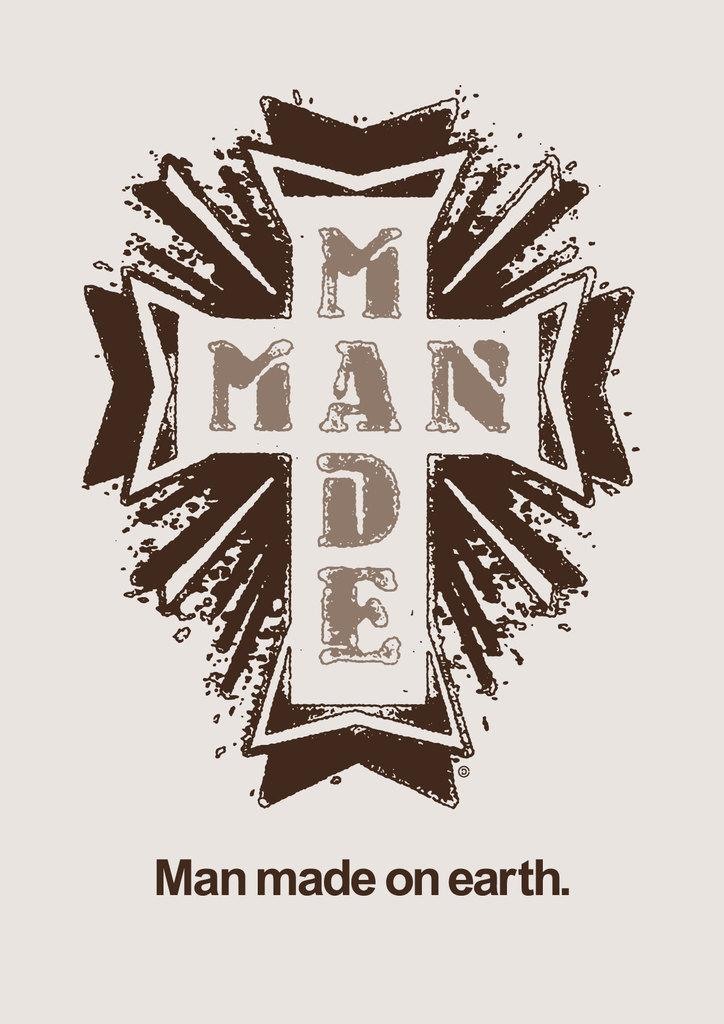Provide a one-sentence caption for the provided image. a white cross with brown shades around it and man made on earth written below it. 